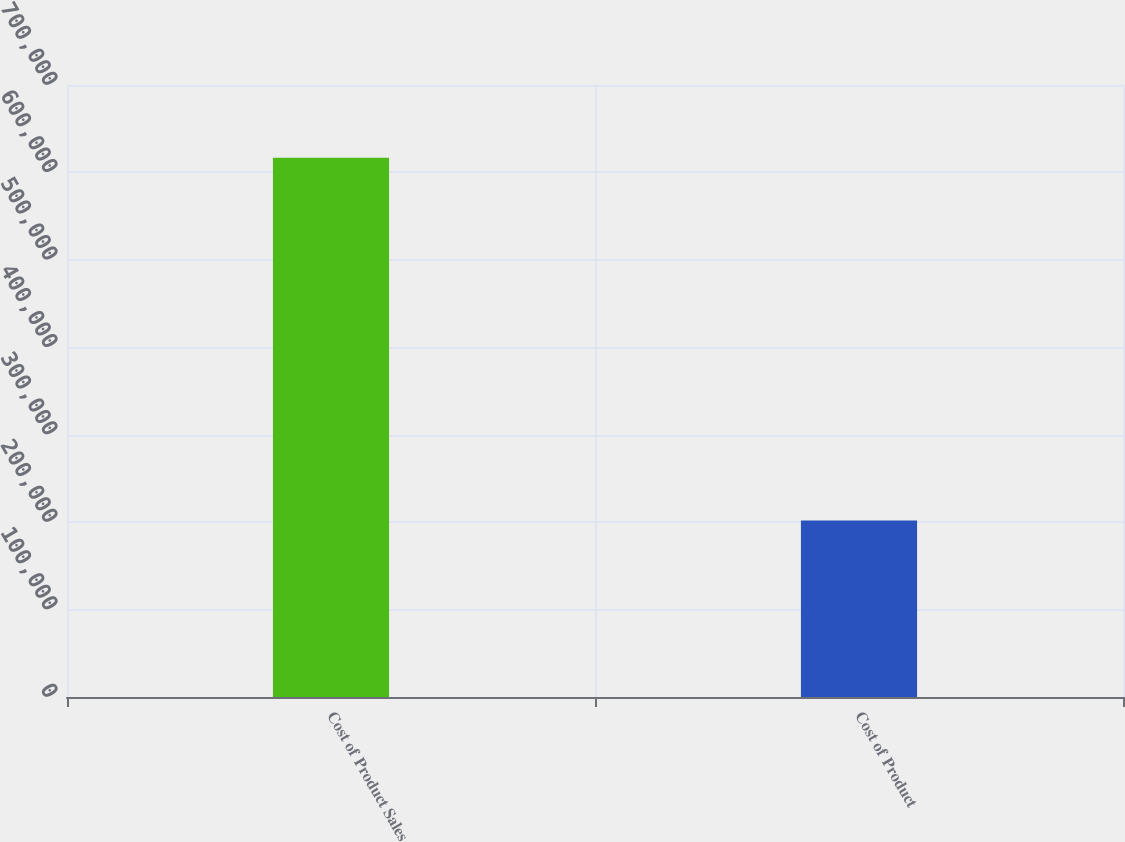Convert chart. <chart><loc_0><loc_0><loc_500><loc_500><bar_chart><fcel>Cost of Product Sales<fcel>Cost of Product<nl><fcel>616839<fcel>201864<nl></chart> 